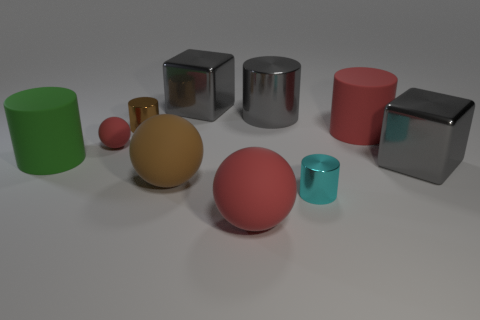Subtract all green cylinders. How many cylinders are left? 4 Subtract all large gray metal cylinders. How many cylinders are left? 4 Subtract all blue cylinders. Subtract all purple cubes. How many cylinders are left? 5 Subtract all spheres. How many objects are left? 7 Subtract 0 blue cubes. How many objects are left? 10 Subtract all large metal objects. Subtract all shiny cylinders. How many objects are left? 4 Add 4 gray cylinders. How many gray cylinders are left? 5 Add 6 metal blocks. How many metal blocks exist? 8 